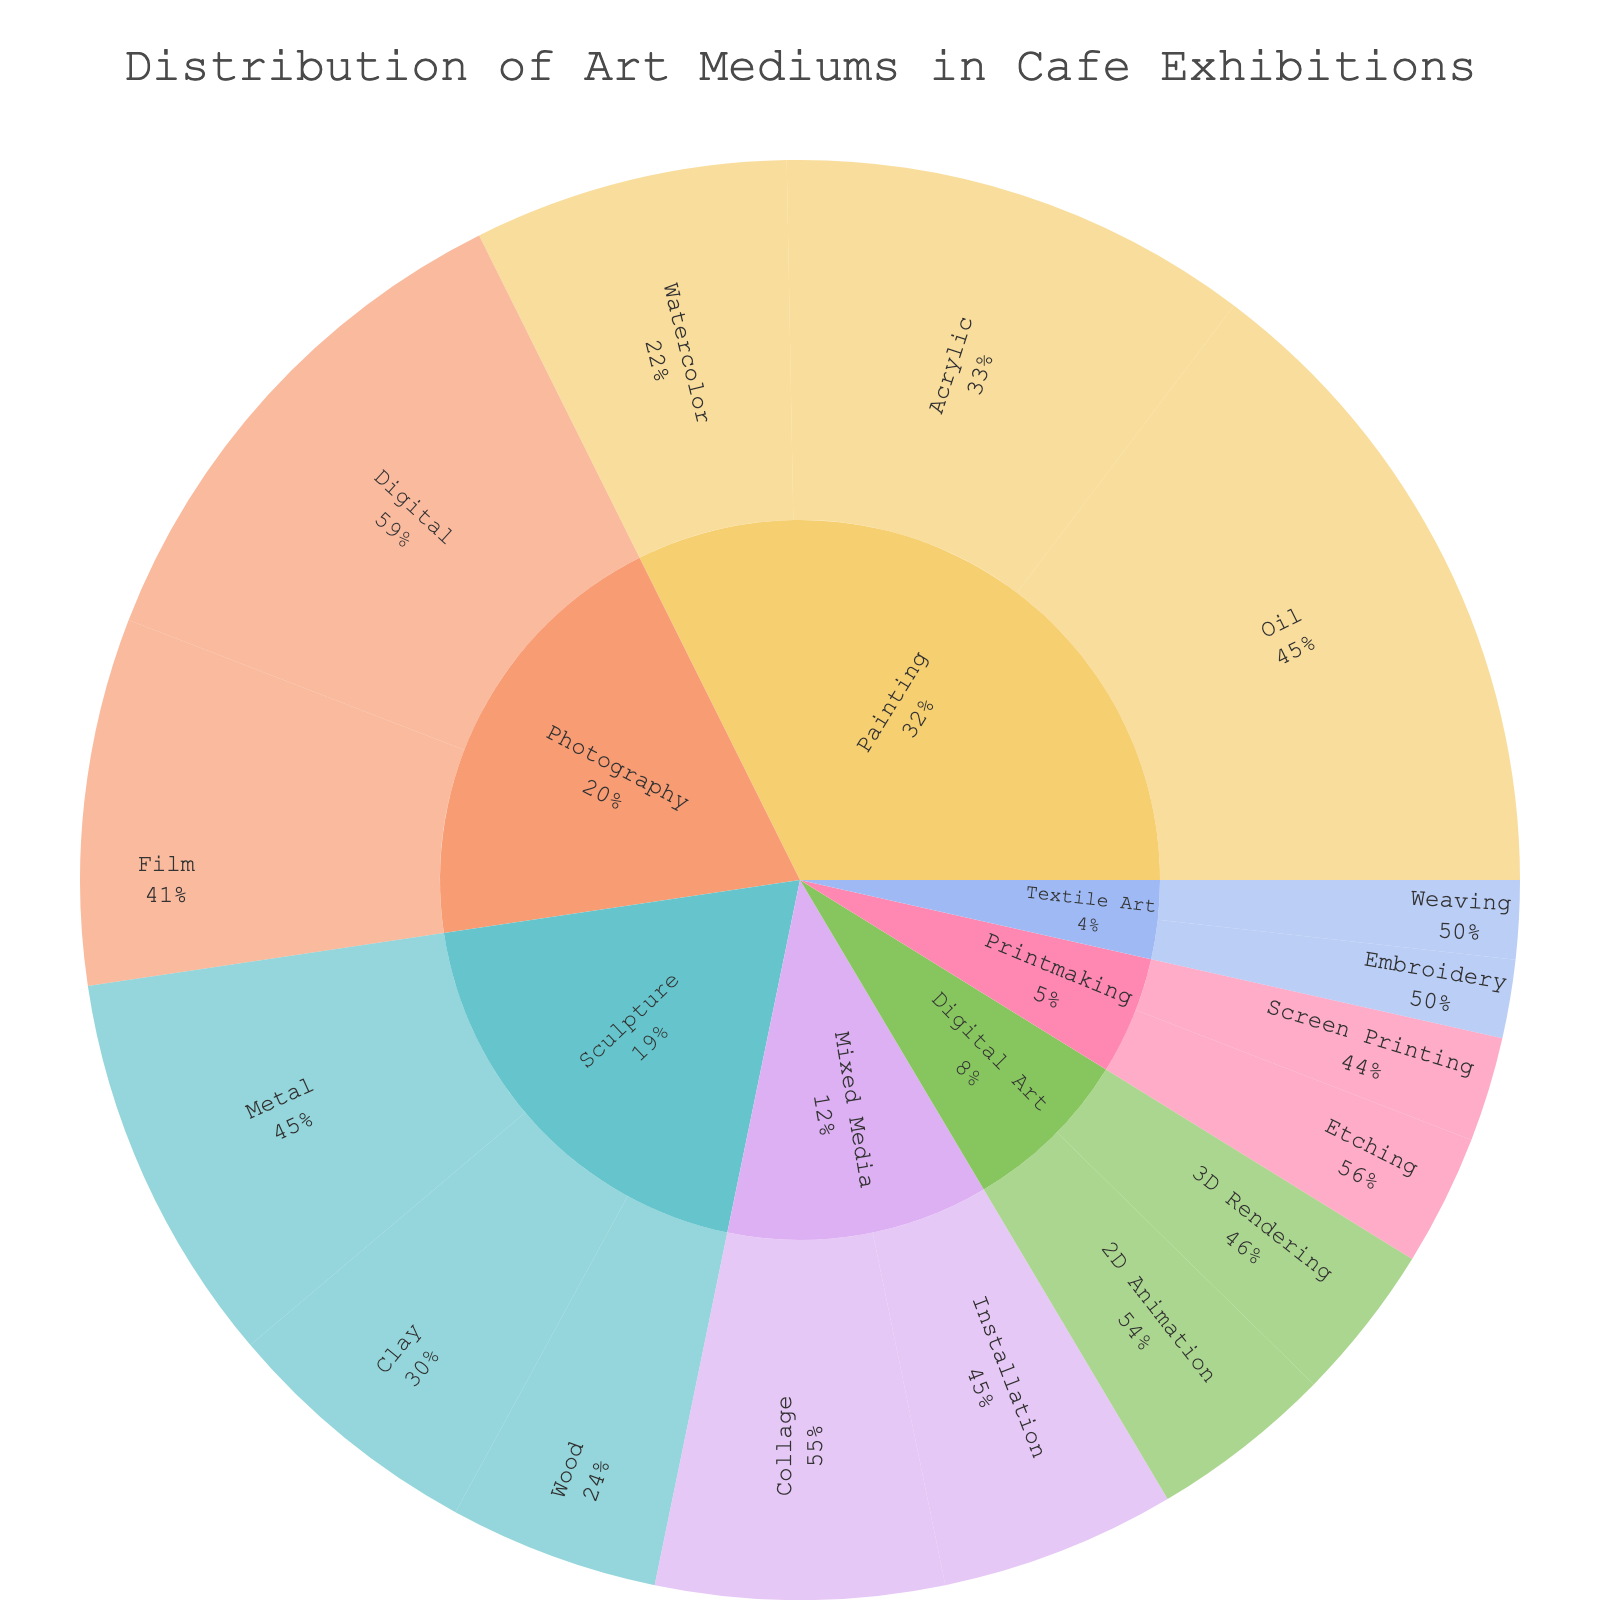What is the title of the sunburst plot? The title is located at the top of the plot and summarizes the information being presented.
Answer: Distribution of Art Mediums in Cafe Exhibitions Which category has the highest overall value? By looking at the largest segments in the sunburst plot, we can determine which category has the highest overall value.
Answer: Painting How many subcategories are there under Sculpture? Count the number of segments directly connected to the 'Sculpture' segment.
Answer: 3 What is the percentage of Oil paintings relative to all paintings? By looking at the percentage label for the Oil painting segment within the Painting category, you can find this information.
Answer: 45.5% Which art medium has the least representation in the plot? The smallest segment within the sunburst plot represents the art medium with the least representation.
Answer: Screen Printing What is the combined value of Digital Photography and Film Photography? To find this, add the values of both Digital (20) and Film (14) under Photography.
Answer: 34 Compare the values of Metal and Clay sculptures. Which one is greater? Find the segments for Metal and Clay under Sculpture and compare their values.
Answer: Metal How many categories have values represented by three subcategories? Look for categories that have exactly three subcategories attached to them.
Answer: 1 What percentage of the total value is contributed by Digital Art? Sum up the values in Digital Art (7 for 2D Animation and 6 for 3D Rendering) and divide by the total sum of all categories, then multiply by 100 to get the percentage.
Answer: 6.9% Which subcategory in Mixed Media has higher value, Collage or Installation? Compare the segments of Collage and Installation under Mixed Media to see which has the higher value.
Answer: Collage 